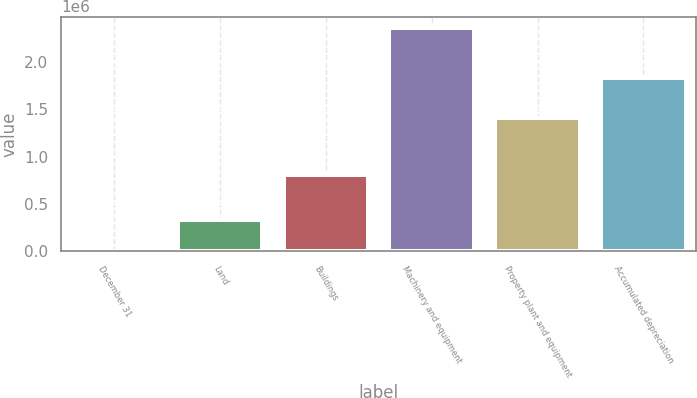<chart> <loc_0><loc_0><loc_500><loc_500><bar_chart><fcel>December 31<fcel>Land<fcel>Buildings<fcel>Machinery and equipment<fcel>Property plant and equipment<fcel>Accumulated depreciation<nl><fcel>2009<fcel>326095<fcel>807155<fcel>2.36532e+06<fcel>1.40477e+06<fcel>1.8381e+06<nl></chart> 